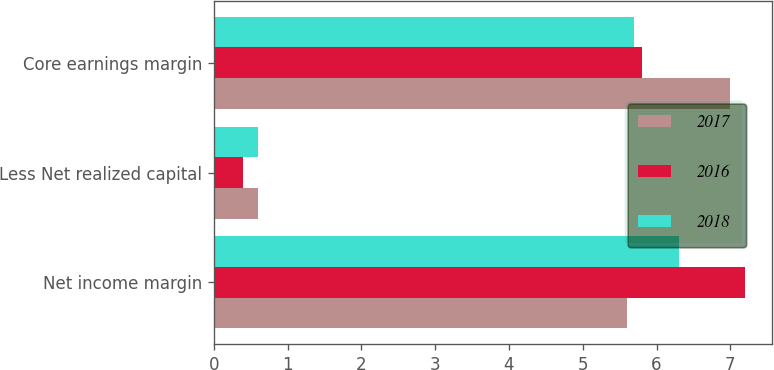Convert chart. <chart><loc_0><loc_0><loc_500><loc_500><stacked_bar_chart><ecel><fcel>Net income margin<fcel>Less Net realized capital<fcel>Core earnings margin<nl><fcel>2017<fcel>5.6<fcel>0.6<fcel>7<nl><fcel>2016<fcel>7.2<fcel>0.4<fcel>5.8<nl><fcel>2018<fcel>6.3<fcel>0.6<fcel>5.7<nl></chart> 